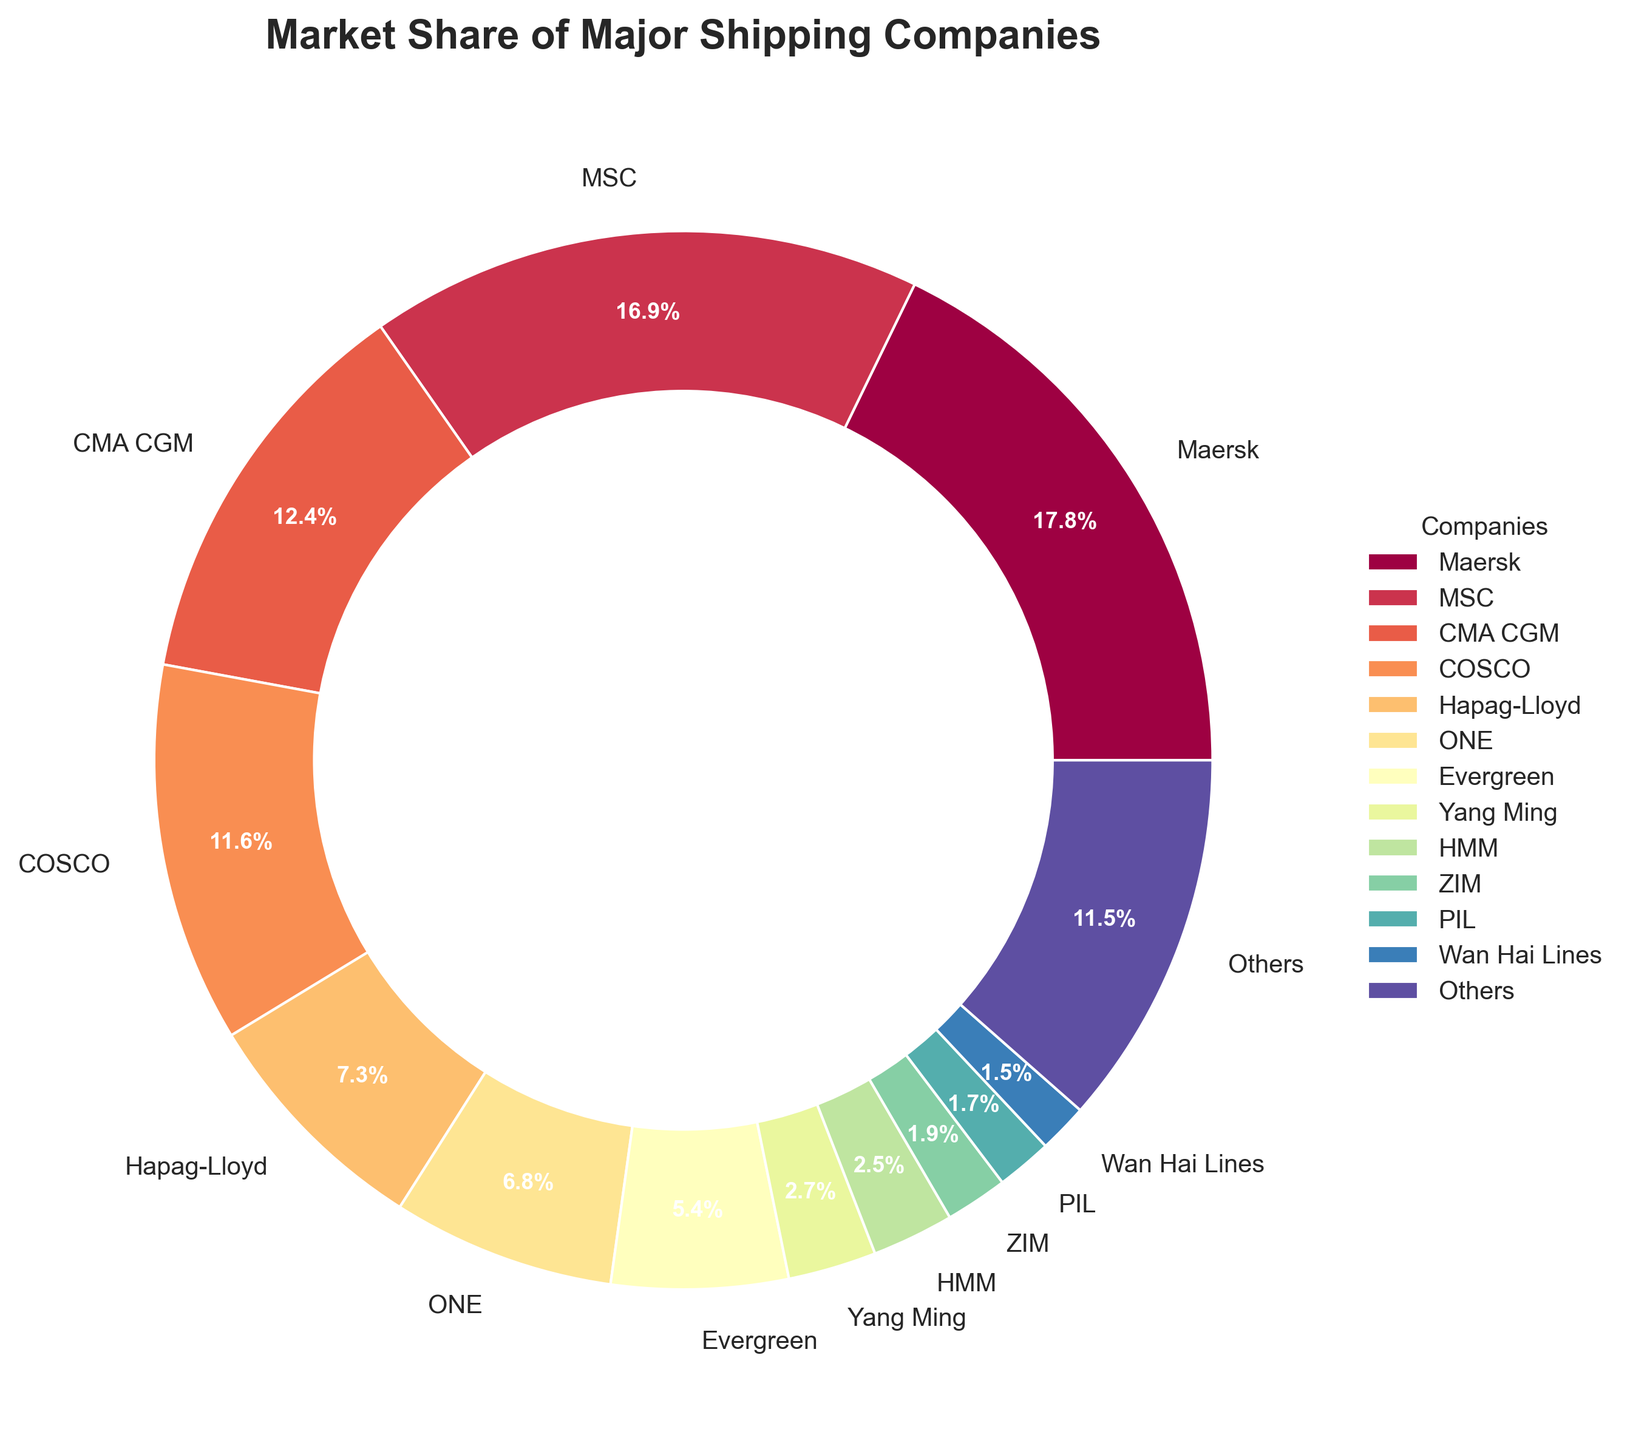Which shipping company has the largest market share? Looking at the chart, the wedge representing the largest market share is labeled "Maersk," which occupies the largest portion of the pie chart.
Answer: Maersk How much larger is Maersk's market share compared to Yang Ming's? The market share for Maersk is 17.8%, while Yang Ming has 2.7%. The difference is calculated as 17.8% - 2.7% = 15.1%.
Answer: 15.1% Which companies together account for over 30% of the market? Adding the market shares of the companies starting from the largest: Maersk (17.8%) + MSC (16.9%) = 34.7%, which is over 30%. So, Maersk and MSC together account for over 30%.
Answer: Maersk and MSC What is the total market share of companies with less than 5% market share each? Summing the market shares of companies with less than 5% each: Yang Ming (2.7%) + HMM (2.5%) + ZIM (1.9%) + PIL (1.7%) + Wan Hai Lines (1.5%) = 10.3%.
Answer: 10.3% How does the market share of Hapag-Lloyd compare to that of ONE? The market share for Hapag-Lloyd is 7.3%, while for ONE, it is 6.8%. Hapag-Lloyd has a slightly larger market share.
Answer: Hapag-Lloyd has a larger share Which company is represented by the color at the top of the color gradient? Observing the colors at the top of the gradient, the first wedge is assigned to Maersk.
Answer: Maersk What is the combined market share of CMA CGM and COSCO? The market share of CMA CGM is 12.4% and COSCO is 11.6%. Adding these gives 12.4% + 11.6% = 24%.
Answer: 24% Is the market share of 'Others' greater than that of Evergreen? The market share of 'Others' is 11.5%, while Evergreen's is 5.4%. Therefore, the market share of 'Others' is greater.
Answer: Yes Which company has the smallest market share, and what is it? The smallest market share belongs to Wan Hai Lines, with a share of 1.5%.
Answer: Wan Hai Lines, 1.5% What is the market share difference between the company with the largest share and the company with the second largest share? Maersk has a market share of 17.8% and MSC has 16.9%. The difference is 17.8% - 16.9% = 0.9%.
Answer: 0.9% 